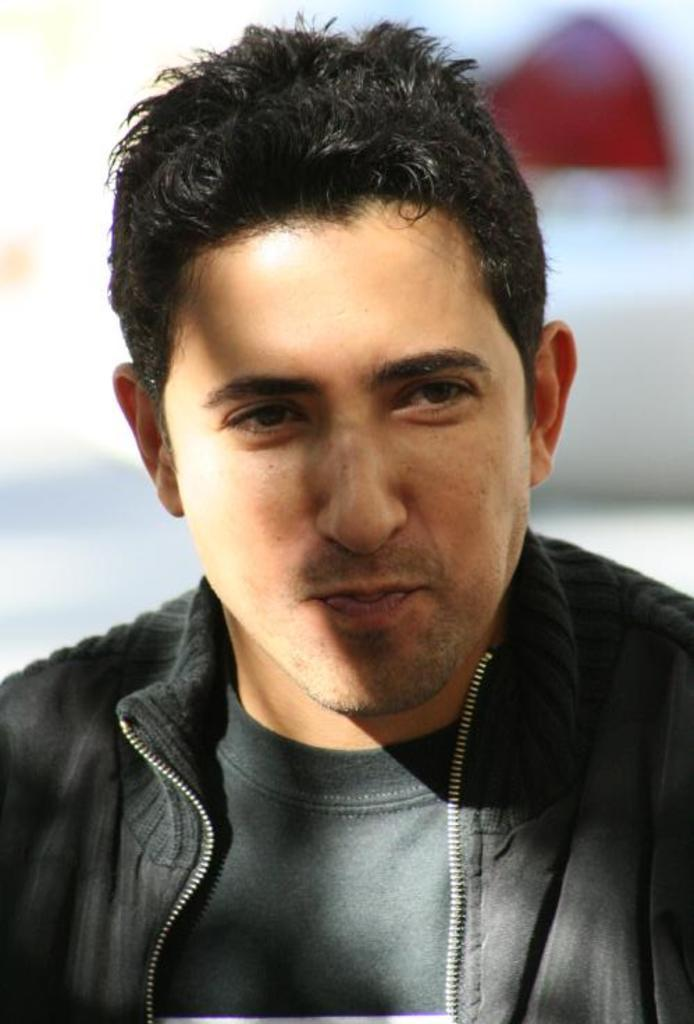What is the main subject of the image? There is a person in the center of the image. Can you describe the background of the image? There is an object in the background of the image. How many rose balloons are being held by the person in the image? There is no rose balloon present in the image. 